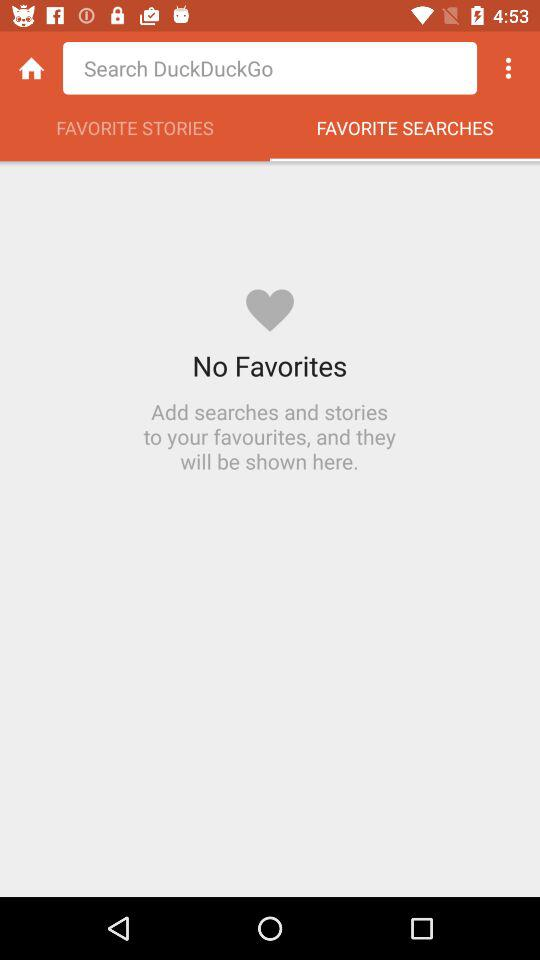How many favorites in total can we add?
When the provided information is insufficient, respond with <no answer>. <no answer> 